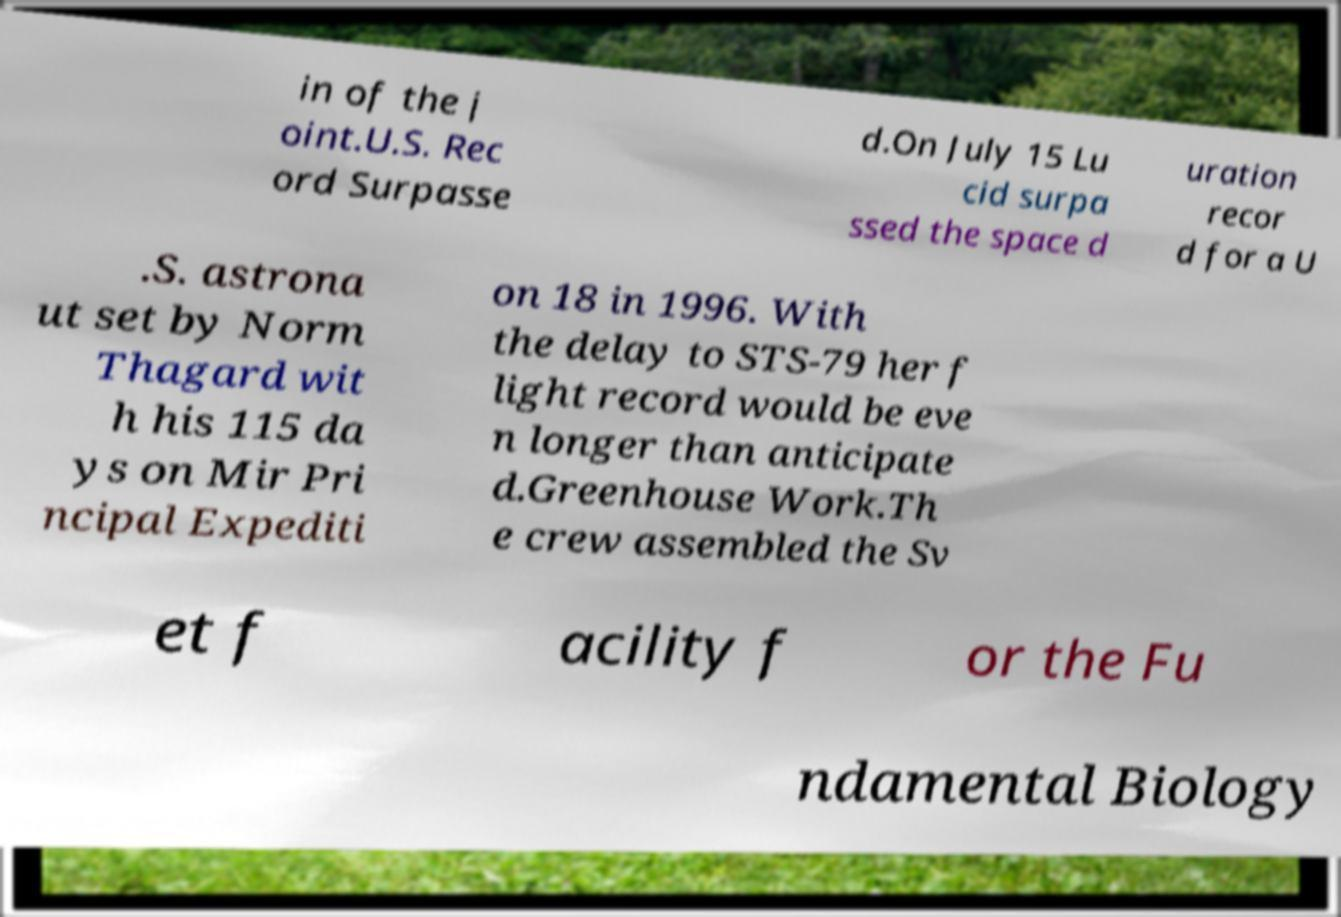For documentation purposes, I need the text within this image transcribed. Could you provide that? in of the j oint.U.S. Rec ord Surpasse d.On July 15 Lu cid surpa ssed the space d uration recor d for a U .S. astrona ut set by Norm Thagard wit h his 115 da ys on Mir Pri ncipal Expediti on 18 in 1996. With the delay to STS-79 her f light record would be eve n longer than anticipate d.Greenhouse Work.Th e crew assembled the Sv et f acility f or the Fu ndamental Biology 